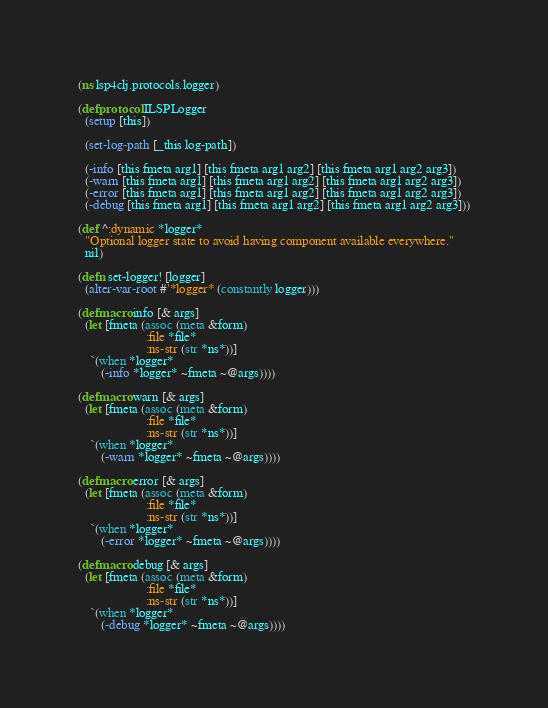Convert code to text. <code><loc_0><loc_0><loc_500><loc_500><_Clojure_>(ns lsp4clj.protocols.logger)

(defprotocol ILSPLogger
  (setup [this])

  (set-log-path [_this log-path])

  (-info [this fmeta arg1] [this fmeta arg1 arg2] [this fmeta arg1 arg2 arg3])
  (-warn [this fmeta arg1] [this fmeta arg1 arg2] [this fmeta arg1 arg2 arg3])
  (-error [this fmeta arg1] [this fmeta arg1 arg2] [this fmeta arg1 arg2 arg3])
  (-debug [this fmeta arg1] [this fmeta arg1 arg2] [this fmeta arg1 arg2 arg3]))

(def ^:dynamic *logger*
  "Optional logger state to avoid having component available everywhere."
  nil)

(defn set-logger! [logger]
  (alter-var-root #'*logger* (constantly logger)))

(defmacro info [& args]
  (let [fmeta (assoc (meta &form)
                     :file *file*
                     :ns-str (str *ns*))]
    `(when *logger*
       (-info *logger* ~fmeta ~@args))))

(defmacro warn [& args]
  (let [fmeta (assoc (meta &form)
                     :file *file*
                     :ns-str (str *ns*))]
    `(when *logger*
       (-warn *logger* ~fmeta ~@args))))

(defmacro error [& args]
  (let [fmeta (assoc (meta &form)
                     :file *file*
                     :ns-str (str *ns*))]
    `(when *logger*
       (-error *logger* ~fmeta ~@args))))

(defmacro debug [& args]
  (let [fmeta (assoc (meta &form)
                     :file *file*
                     :ns-str (str *ns*))]
    `(when *logger*
       (-debug *logger* ~fmeta ~@args))))
</code> 